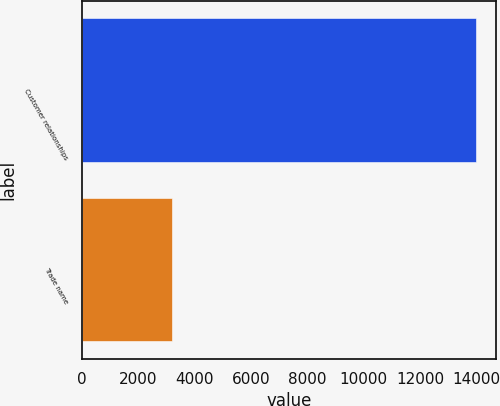Convert chart. <chart><loc_0><loc_0><loc_500><loc_500><bar_chart><fcel>Customer relationships<fcel>Trade name<nl><fcel>13997<fcel>3194<nl></chart> 